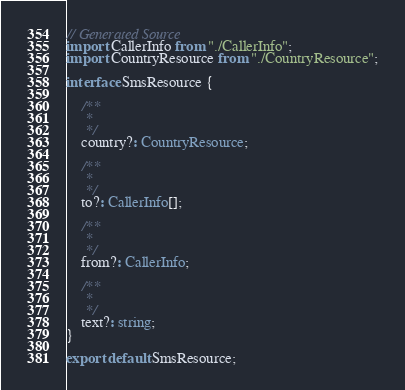Convert code to text. <code><loc_0><loc_0><loc_500><loc_500><_TypeScript_>// Generated Source
import CallerInfo from "./CallerInfo";
import CountryResource from "./CountryResource";

interface SmsResource {

    /**
     * 
     */
    country?: CountryResource;

    /**
     * 
     */
    to?: CallerInfo[];

    /**
     * 
     */
    from?: CallerInfo;

    /**
     * 
     */
    text?: string;
}

export default SmsResource;
</code> 